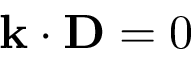Convert formula to latex. <formula><loc_0><loc_0><loc_500><loc_500>k \cdot D = 0</formula> 